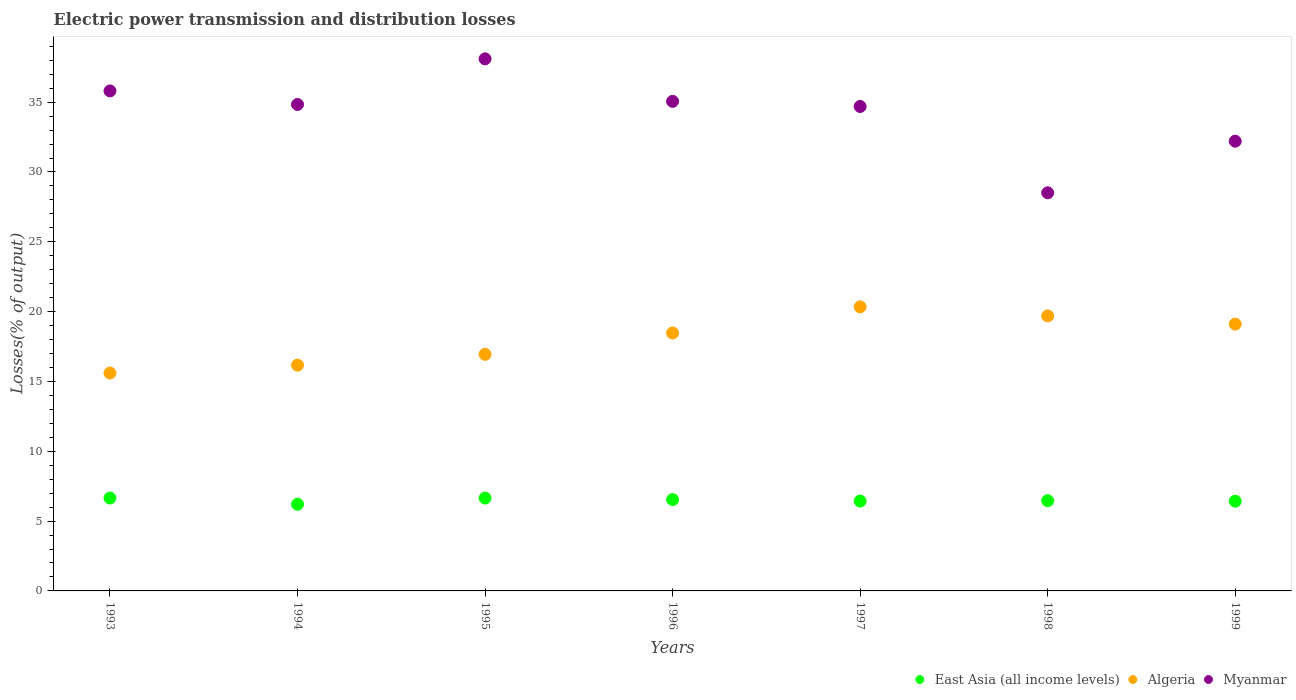Is the number of dotlines equal to the number of legend labels?
Your answer should be compact. Yes. What is the electric power transmission and distribution losses in Algeria in 1999?
Provide a short and direct response. 19.11. Across all years, what is the maximum electric power transmission and distribution losses in Myanmar?
Provide a succinct answer. 38.1. Across all years, what is the minimum electric power transmission and distribution losses in East Asia (all income levels)?
Your response must be concise. 6.21. In which year was the electric power transmission and distribution losses in Myanmar minimum?
Make the answer very short. 1998. What is the total electric power transmission and distribution losses in Algeria in the graph?
Your answer should be compact. 126.32. What is the difference between the electric power transmission and distribution losses in Algeria in 1995 and that in 1998?
Provide a succinct answer. -2.75. What is the difference between the electric power transmission and distribution losses in East Asia (all income levels) in 1993 and the electric power transmission and distribution losses in Algeria in 1994?
Your answer should be very brief. -9.51. What is the average electric power transmission and distribution losses in East Asia (all income levels) per year?
Give a very brief answer. 6.48. In the year 1994, what is the difference between the electric power transmission and distribution losses in East Asia (all income levels) and electric power transmission and distribution losses in Algeria?
Provide a short and direct response. -9.96. What is the ratio of the electric power transmission and distribution losses in Myanmar in 1997 to that in 1999?
Your answer should be very brief. 1.08. Is the difference between the electric power transmission and distribution losses in East Asia (all income levels) in 1993 and 1995 greater than the difference between the electric power transmission and distribution losses in Algeria in 1993 and 1995?
Your answer should be compact. Yes. What is the difference between the highest and the second highest electric power transmission and distribution losses in Myanmar?
Ensure brevity in your answer.  2.3. What is the difference between the highest and the lowest electric power transmission and distribution losses in Myanmar?
Provide a succinct answer. 9.59. In how many years, is the electric power transmission and distribution losses in Myanmar greater than the average electric power transmission and distribution losses in Myanmar taken over all years?
Offer a very short reply. 5. Is the sum of the electric power transmission and distribution losses in Algeria in 1995 and 1999 greater than the maximum electric power transmission and distribution losses in Myanmar across all years?
Ensure brevity in your answer.  No. Does the electric power transmission and distribution losses in East Asia (all income levels) monotonically increase over the years?
Provide a short and direct response. No. Is the electric power transmission and distribution losses in Algeria strictly less than the electric power transmission and distribution losses in East Asia (all income levels) over the years?
Your answer should be very brief. No. How many years are there in the graph?
Provide a short and direct response. 7. What is the difference between two consecutive major ticks on the Y-axis?
Make the answer very short. 5. Are the values on the major ticks of Y-axis written in scientific E-notation?
Offer a terse response. No. Does the graph contain grids?
Offer a terse response. No. Where does the legend appear in the graph?
Provide a succinct answer. Bottom right. How many legend labels are there?
Ensure brevity in your answer.  3. How are the legend labels stacked?
Keep it short and to the point. Horizontal. What is the title of the graph?
Give a very brief answer. Electric power transmission and distribution losses. What is the label or title of the Y-axis?
Provide a short and direct response. Losses(% of output). What is the Losses(% of output) of East Asia (all income levels) in 1993?
Provide a short and direct response. 6.65. What is the Losses(% of output) in Algeria in 1993?
Provide a short and direct response. 15.6. What is the Losses(% of output) of Myanmar in 1993?
Make the answer very short. 35.81. What is the Losses(% of output) in East Asia (all income levels) in 1994?
Your response must be concise. 6.21. What is the Losses(% of output) of Algeria in 1994?
Your response must be concise. 16.16. What is the Losses(% of output) in Myanmar in 1994?
Give a very brief answer. 34.84. What is the Losses(% of output) of East Asia (all income levels) in 1995?
Your answer should be compact. 6.65. What is the Losses(% of output) in Algeria in 1995?
Offer a terse response. 16.94. What is the Losses(% of output) in Myanmar in 1995?
Provide a short and direct response. 38.1. What is the Losses(% of output) of East Asia (all income levels) in 1996?
Ensure brevity in your answer.  6.54. What is the Losses(% of output) in Algeria in 1996?
Provide a succinct answer. 18.47. What is the Losses(% of output) in Myanmar in 1996?
Your response must be concise. 35.06. What is the Losses(% of output) in East Asia (all income levels) in 1997?
Keep it short and to the point. 6.43. What is the Losses(% of output) in Algeria in 1997?
Ensure brevity in your answer.  20.34. What is the Losses(% of output) in Myanmar in 1997?
Your answer should be compact. 34.69. What is the Losses(% of output) in East Asia (all income levels) in 1998?
Offer a very short reply. 6.46. What is the Losses(% of output) of Algeria in 1998?
Provide a succinct answer. 19.69. What is the Losses(% of output) of Myanmar in 1998?
Provide a succinct answer. 28.51. What is the Losses(% of output) in East Asia (all income levels) in 1999?
Give a very brief answer. 6.42. What is the Losses(% of output) in Algeria in 1999?
Ensure brevity in your answer.  19.11. What is the Losses(% of output) of Myanmar in 1999?
Offer a very short reply. 32.21. Across all years, what is the maximum Losses(% of output) in East Asia (all income levels)?
Your answer should be very brief. 6.65. Across all years, what is the maximum Losses(% of output) of Algeria?
Your answer should be very brief. 20.34. Across all years, what is the maximum Losses(% of output) in Myanmar?
Your answer should be very brief. 38.1. Across all years, what is the minimum Losses(% of output) of East Asia (all income levels)?
Keep it short and to the point. 6.21. Across all years, what is the minimum Losses(% of output) in Algeria?
Offer a terse response. 15.6. Across all years, what is the minimum Losses(% of output) in Myanmar?
Your answer should be very brief. 28.51. What is the total Losses(% of output) in East Asia (all income levels) in the graph?
Offer a very short reply. 45.37. What is the total Losses(% of output) in Algeria in the graph?
Offer a terse response. 126.32. What is the total Losses(% of output) of Myanmar in the graph?
Make the answer very short. 239.2. What is the difference between the Losses(% of output) in East Asia (all income levels) in 1993 and that in 1994?
Your answer should be very brief. 0.45. What is the difference between the Losses(% of output) in Algeria in 1993 and that in 1994?
Offer a terse response. -0.56. What is the difference between the Losses(% of output) of Myanmar in 1993 and that in 1994?
Provide a succinct answer. 0.97. What is the difference between the Losses(% of output) of East Asia (all income levels) in 1993 and that in 1995?
Your response must be concise. 0. What is the difference between the Losses(% of output) in Algeria in 1993 and that in 1995?
Make the answer very short. -1.34. What is the difference between the Losses(% of output) of Myanmar in 1993 and that in 1995?
Keep it short and to the point. -2.3. What is the difference between the Losses(% of output) in East Asia (all income levels) in 1993 and that in 1996?
Offer a very short reply. 0.11. What is the difference between the Losses(% of output) in Algeria in 1993 and that in 1996?
Ensure brevity in your answer.  -2.87. What is the difference between the Losses(% of output) of Myanmar in 1993 and that in 1996?
Make the answer very short. 0.75. What is the difference between the Losses(% of output) of East Asia (all income levels) in 1993 and that in 1997?
Your response must be concise. 0.22. What is the difference between the Losses(% of output) of Algeria in 1993 and that in 1997?
Your answer should be very brief. -4.74. What is the difference between the Losses(% of output) of Myanmar in 1993 and that in 1997?
Your answer should be compact. 1.11. What is the difference between the Losses(% of output) in East Asia (all income levels) in 1993 and that in 1998?
Keep it short and to the point. 0.19. What is the difference between the Losses(% of output) of Algeria in 1993 and that in 1998?
Offer a terse response. -4.09. What is the difference between the Losses(% of output) in Myanmar in 1993 and that in 1998?
Offer a terse response. 7.3. What is the difference between the Losses(% of output) of East Asia (all income levels) in 1993 and that in 1999?
Provide a succinct answer. 0.23. What is the difference between the Losses(% of output) in Algeria in 1993 and that in 1999?
Offer a very short reply. -3.5. What is the difference between the Losses(% of output) in Myanmar in 1993 and that in 1999?
Your answer should be compact. 3.6. What is the difference between the Losses(% of output) of East Asia (all income levels) in 1994 and that in 1995?
Provide a succinct answer. -0.44. What is the difference between the Losses(% of output) in Algeria in 1994 and that in 1995?
Ensure brevity in your answer.  -0.78. What is the difference between the Losses(% of output) of Myanmar in 1994 and that in 1995?
Your answer should be compact. -3.27. What is the difference between the Losses(% of output) of East Asia (all income levels) in 1994 and that in 1996?
Your response must be concise. -0.34. What is the difference between the Losses(% of output) of Algeria in 1994 and that in 1996?
Offer a very short reply. -2.31. What is the difference between the Losses(% of output) of Myanmar in 1994 and that in 1996?
Provide a short and direct response. -0.22. What is the difference between the Losses(% of output) in East Asia (all income levels) in 1994 and that in 1997?
Provide a short and direct response. -0.23. What is the difference between the Losses(% of output) in Algeria in 1994 and that in 1997?
Give a very brief answer. -4.18. What is the difference between the Losses(% of output) of Myanmar in 1994 and that in 1997?
Offer a terse response. 0.15. What is the difference between the Losses(% of output) of East Asia (all income levels) in 1994 and that in 1998?
Offer a terse response. -0.26. What is the difference between the Losses(% of output) in Algeria in 1994 and that in 1998?
Your answer should be very brief. -3.53. What is the difference between the Losses(% of output) of Myanmar in 1994 and that in 1998?
Your response must be concise. 6.33. What is the difference between the Losses(% of output) in East Asia (all income levels) in 1994 and that in 1999?
Provide a succinct answer. -0.22. What is the difference between the Losses(% of output) of Algeria in 1994 and that in 1999?
Your response must be concise. -2.94. What is the difference between the Losses(% of output) in Myanmar in 1994 and that in 1999?
Provide a short and direct response. 2.63. What is the difference between the Losses(% of output) of East Asia (all income levels) in 1995 and that in 1996?
Ensure brevity in your answer.  0.11. What is the difference between the Losses(% of output) of Algeria in 1995 and that in 1996?
Keep it short and to the point. -1.53. What is the difference between the Losses(% of output) in Myanmar in 1995 and that in 1996?
Ensure brevity in your answer.  3.04. What is the difference between the Losses(% of output) in East Asia (all income levels) in 1995 and that in 1997?
Ensure brevity in your answer.  0.22. What is the difference between the Losses(% of output) of Algeria in 1995 and that in 1997?
Offer a very short reply. -3.4. What is the difference between the Losses(% of output) of Myanmar in 1995 and that in 1997?
Your answer should be very brief. 3.41. What is the difference between the Losses(% of output) in East Asia (all income levels) in 1995 and that in 1998?
Offer a terse response. 0.19. What is the difference between the Losses(% of output) of Algeria in 1995 and that in 1998?
Your response must be concise. -2.75. What is the difference between the Losses(% of output) in Myanmar in 1995 and that in 1998?
Ensure brevity in your answer.  9.59. What is the difference between the Losses(% of output) in East Asia (all income levels) in 1995 and that in 1999?
Your answer should be very brief. 0.22. What is the difference between the Losses(% of output) of Algeria in 1995 and that in 1999?
Provide a short and direct response. -2.16. What is the difference between the Losses(% of output) in Myanmar in 1995 and that in 1999?
Give a very brief answer. 5.9. What is the difference between the Losses(% of output) of East Asia (all income levels) in 1996 and that in 1997?
Provide a short and direct response. 0.11. What is the difference between the Losses(% of output) of Algeria in 1996 and that in 1997?
Give a very brief answer. -1.87. What is the difference between the Losses(% of output) of Myanmar in 1996 and that in 1997?
Offer a very short reply. 0.37. What is the difference between the Losses(% of output) in East Asia (all income levels) in 1996 and that in 1998?
Your answer should be very brief. 0.08. What is the difference between the Losses(% of output) of Algeria in 1996 and that in 1998?
Your answer should be very brief. -1.22. What is the difference between the Losses(% of output) of Myanmar in 1996 and that in 1998?
Your answer should be compact. 6.55. What is the difference between the Losses(% of output) of East Asia (all income levels) in 1996 and that in 1999?
Offer a terse response. 0.12. What is the difference between the Losses(% of output) of Algeria in 1996 and that in 1999?
Keep it short and to the point. -0.63. What is the difference between the Losses(% of output) in Myanmar in 1996 and that in 1999?
Give a very brief answer. 2.85. What is the difference between the Losses(% of output) in East Asia (all income levels) in 1997 and that in 1998?
Your answer should be very brief. -0.03. What is the difference between the Losses(% of output) of Algeria in 1997 and that in 1998?
Give a very brief answer. 0.65. What is the difference between the Losses(% of output) in Myanmar in 1997 and that in 1998?
Your answer should be compact. 6.18. What is the difference between the Losses(% of output) in East Asia (all income levels) in 1997 and that in 1999?
Give a very brief answer. 0.01. What is the difference between the Losses(% of output) in Algeria in 1997 and that in 1999?
Offer a terse response. 1.24. What is the difference between the Losses(% of output) of Myanmar in 1997 and that in 1999?
Your answer should be compact. 2.49. What is the difference between the Losses(% of output) of East Asia (all income levels) in 1998 and that in 1999?
Provide a succinct answer. 0.04. What is the difference between the Losses(% of output) in Algeria in 1998 and that in 1999?
Provide a succinct answer. 0.59. What is the difference between the Losses(% of output) of Myanmar in 1998 and that in 1999?
Make the answer very short. -3.7. What is the difference between the Losses(% of output) in East Asia (all income levels) in 1993 and the Losses(% of output) in Algeria in 1994?
Give a very brief answer. -9.51. What is the difference between the Losses(% of output) in East Asia (all income levels) in 1993 and the Losses(% of output) in Myanmar in 1994?
Make the answer very short. -28.18. What is the difference between the Losses(% of output) of Algeria in 1993 and the Losses(% of output) of Myanmar in 1994?
Provide a short and direct response. -19.23. What is the difference between the Losses(% of output) of East Asia (all income levels) in 1993 and the Losses(% of output) of Algeria in 1995?
Keep it short and to the point. -10.29. What is the difference between the Losses(% of output) of East Asia (all income levels) in 1993 and the Losses(% of output) of Myanmar in 1995?
Ensure brevity in your answer.  -31.45. What is the difference between the Losses(% of output) in Algeria in 1993 and the Losses(% of output) in Myanmar in 1995?
Your answer should be compact. -22.5. What is the difference between the Losses(% of output) in East Asia (all income levels) in 1993 and the Losses(% of output) in Algeria in 1996?
Provide a short and direct response. -11.82. What is the difference between the Losses(% of output) in East Asia (all income levels) in 1993 and the Losses(% of output) in Myanmar in 1996?
Provide a short and direct response. -28.41. What is the difference between the Losses(% of output) of Algeria in 1993 and the Losses(% of output) of Myanmar in 1996?
Offer a very short reply. -19.45. What is the difference between the Losses(% of output) in East Asia (all income levels) in 1993 and the Losses(% of output) in Algeria in 1997?
Provide a short and direct response. -13.69. What is the difference between the Losses(% of output) in East Asia (all income levels) in 1993 and the Losses(% of output) in Myanmar in 1997?
Give a very brief answer. -28.04. What is the difference between the Losses(% of output) in Algeria in 1993 and the Losses(% of output) in Myanmar in 1997?
Your answer should be compact. -19.09. What is the difference between the Losses(% of output) of East Asia (all income levels) in 1993 and the Losses(% of output) of Algeria in 1998?
Your response must be concise. -13.04. What is the difference between the Losses(% of output) of East Asia (all income levels) in 1993 and the Losses(% of output) of Myanmar in 1998?
Offer a very short reply. -21.86. What is the difference between the Losses(% of output) in Algeria in 1993 and the Losses(% of output) in Myanmar in 1998?
Your response must be concise. -12.91. What is the difference between the Losses(% of output) of East Asia (all income levels) in 1993 and the Losses(% of output) of Algeria in 1999?
Provide a succinct answer. -12.45. What is the difference between the Losses(% of output) of East Asia (all income levels) in 1993 and the Losses(% of output) of Myanmar in 1999?
Offer a terse response. -25.55. What is the difference between the Losses(% of output) in Algeria in 1993 and the Losses(% of output) in Myanmar in 1999?
Give a very brief answer. -16.6. What is the difference between the Losses(% of output) of East Asia (all income levels) in 1994 and the Losses(% of output) of Algeria in 1995?
Ensure brevity in your answer.  -10.74. What is the difference between the Losses(% of output) of East Asia (all income levels) in 1994 and the Losses(% of output) of Myanmar in 1995?
Offer a terse response. -31.9. What is the difference between the Losses(% of output) of Algeria in 1994 and the Losses(% of output) of Myanmar in 1995?
Provide a succinct answer. -21.94. What is the difference between the Losses(% of output) of East Asia (all income levels) in 1994 and the Losses(% of output) of Algeria in 1996?
Offer a terse response. -12.27. What is the difference between the Losses(% of output) of East Asia (all income levels) in 1994 and the Losses(% of output) of Myanmar in 1996?
Your response must be concise. -28.85. What is the difference between the Losses(% of output) of Algeria in 1994 and the Losses(% of output) of Myanmar in 1996?
Provide a short and direct response. -18.89. What is the difference between the Losses(% of output) of East Asia (all income levels) in 1994 and the Losses(% of output) of Algeria in 1997?
Give a very brief answer. -14.14. What is the difference between the Losses(% of output) in East Asia (all income levels) in 1994 and the Losses(% of output) in Myanmar in 1997?
Make the answer very short. -28.48. What is the difference between the Losses(% of output) of Algeria in 1994 and the Losses(% of output) of Myanmar in 1997?
Your answer should be compact. -18.53. What is the difference between the Losses(% of output) of East Asia (all income levels) in 1994 and the Losses(% of output) of Algeria in 1998?
Your answer should be compact. -13.49. What is the difference between the Losses(% of output) in East Asia (all income levels) in 1994 and the Losses(% of output) in Myanmar in 1998?
Make the answer very short. -22.3. What is the difference between the Losses(% of output) of Algeria in 1994 and the Losses(% of output) of Myanmar in 1998?
Your answer should be very brief. -12.34. What is the difference between the Losses(% of output) in East Asia (all income levels) in 1994 and the Losses(% of output) in Algeria in 1999?
Provide a short and direct response. -12.9. What is the difference between the Losses(% of output) in East Asia (all income levels) in 1994 and the Losses(% of output) in Myanmar in 1999?
Provide a succinct answer. -26. What is the difference between the Losses(% of output) in Algeria in 1994 and the Losses(% of output) in Myanmar in 1999?
Your response must be concise. -16.04. What is the difference between the Losses(% of output) of East Asia (all income levels) in 1995 and the Losses(% of output) of Algeria in 1996?
Ensure brevity in your answer.  -11.82. What is the difference between the Losses(% of output) of East Asia (all income levels) in 1995 and the Losses(% of output) of Myanmar in 1996?
Provide a succinct answer. -28.41. What is the difference between the Losses(% of output) of Algeria in 1995 and the Losses(% of output) of Myanmar in 1996?
Offer a terse response. -18.12. What is the difference between the Losses(% of output) in East Asia (all income levels) in 1995 and the Losses(% of output) in Algeria in 1997?
Your answer should be compact. -13.69. What is the difference between the Losses(% of output) of East Asia (all income levels) in 1995 and the Losses(% of output) of Myanmar in 1997?
Your answer should be very brief. -28.04. What is the difference between the Losses(% of output) in Algeria in 1995 and the Losses(% of output) in Myanmar in 1997?
Give a very brief answer. -17.75. What is the difference between the Losses(% of output) in East Asia (all income levels) in 1995 and the Losses(% of output) in Algeria in 1998?
Offer a very short reply. -13.04. What is the difference between the Losses(% of output) in East Asia (all income levels) in 1995 and the Losses(% of output) in Myanmar in 1998?
Keep it short and to the point. -21.86. What is the difference between the Losses(% of output) in Algeria in 1995 and the Losses(% of output) in Myanmar in 1998?
Make the answer very short. -11.57. What is the difference between the Losses(% of output) in East Asia (all income levels) in 1995 and the Losses(% of output) in Algeria in 1999?
Provide a succinct answer. -12.46. What is the difference between the Losses(% of output) of East Asia (all income levels) in 1995 and the Losses(% of output) of Myanmar in 1999?
Provide a succinct answer. -25.56. What is the difference between the Losses(% of output) of Algeria in 1995 and the Losses(% of output) of Myanmar in 1999?
Give a very brief answer. -15.26. What is the difference between the Losses(% of output) of East Asia (all income levels) in 1996 and the Losses(% of output) of Algeria in 1997?
Ensure brevity in your answer.  -13.8. What is the difference between the Losses(% of output) of East Asia (all income levels) in 1996 and the Losses(% of output) of Myanmar in 1997?
Offer a very short reply. -28.15. What is the difference between the Losses(% of output) of Algeria in 1996 and the Losses(% of output) of Myanmar in 1997?
Your answer should be very brief. -16.22. What is the difference between the Losses(% of output) in East Asia (all income levels) in 1996 and the Losses(% of output) in Algeria in 1998?
Offer a terse response. -13.15. What is the difference between the Losses(% of output) in East Asia (all income levels) in 1996 and the Losses(% of output) in Myanmar in 1998?
Keep it short and to the point. -21.97. What is the difference between the Losses(% of output) of Algeria in 1996 and the Losses(% of output) of Myanmar in 1998?
Offer a very short reply. -10.04. What is the difference between the Losses(% of output) of East Asia (all income levels) in 1996 and the Losses(% of output) of Algeria in 1999?
Make the answer very short. -12.56. What is the difference between the Losses(% of output) in East Asia (all income levels) in 1996 and the Losses(% of output) in Myanmar in 1999?
Provide a short and direct response. -25.66. What is the difference between the Losses(% of output) of Algeria in 1996 and the Losses(% of output) of Myanmar in 1999?
Your answer should be compact. -13.73. What is the difference between the Losses(% of output) in East Asia (all income levels) in 1997 and the Losses(% of output) in Algeria in 1998?
Provide a succinct answer. -13.26. What is the difference between the Losses(% of output) in East Asia (all income levels) in 1997 and the Losses(% of output) in Myanmar in 1998?
Give a very brief answer. -22.08. What is the difference between the Losses(% of output) in Algeria in 1997 and the Losses(% of output) in Myanmar in 1998?
Make the answer very short. -8.17. What is the difference between the Losses(% of output) in East Asia (all income levels) in 1997 and the Losses(% of output) in Algeria in 1999?
Your answer should be very brief. -12.67. What is the difference between the Losses(% of output) of East Asia (all income levels) in 1997 and the Losses(% of output) of Myanmar in 1999?
Offer a terse response. -25.77. What is the difference between the Losses(% of output) in Algeria in 1997 and the Losses(% of output) in Myanmar in 1999?
Ensure brevity in your answer.  -11.86. What is the difference between the Losses(% of output) in East Asia (all income levels) in 1998 and the Losses(% of output) in Algeria in 1999?
Offer a very short reply. -12.64. What is the difference between the Losses(% of output) in East Asia (all income levels) in 1998 and the Losses(% of output) in Myanmar in 1999?
Keep it short and to the point. -25.74. What is the difference between the Losses(% of output) of Algeria in 1998 and the Losses(% of output) of Myanmar in 1999?
Your response must be concise. -12.51. What is the average Losses(% of output) of East Asia (all income levels) per year?
Provide a short and direct response. 6.48. What is the average Losses(% of output) in Algeria per year?
Give a very brief answer. 18.05. What is the average Losses(% of output) of Myanmar per year?
Offer a very short reply. 34.17. In the year 1993, what is the difference between the Losses(% of output) of East Asia (all income levels) and Losses(% of output) of Algeria?
Your answer should be very brief. -8.95. In the year 1993, what is the difference between the Losses(% of output) in East Asia (all income levels) and Losses(% of output) in Myanmar?
Provide a short and direct response. -29.15. In the year 1993, what is the difference between the Losses(% of output) in Algeria and Losses(% of output) in Myanmar?
Provide a succinct answer. -20.2. In the year 1994, what is the difference between the Losses(% of output) of East Asia (all income levels) and Losses(% of output) of Algeria?
Keep it short and to the point. -9.96. In the year 1994, what is the difference between the Losses(% of output) of East Asia (all income levels) and Losses(% of output) of Myanmar?
Give a very brief answer. -28.63. In the year 1994, what is the difference between the Losses(% of output) in Algeria and Losses(% of output) in Myanmar?
Keep it short and to the point. -18.67. In the year 1995, what is the difference between the Losses(% of output) in East Asia (all income levels) and Losses(% of output) in Algeria?
Keep it short and to the point. -10.29. In the year 1995, what is the difference between the Losses(% of output) in East Asia (all income levels) and Losses(% of output) in Myanmar?
Provide a short and direct response. -31.45. In the year 1995, what is the difference between the Losses(% of output) of Algeria and Losses(% of output) of Myanmar?
Offer a terse response. -21.16. In the year 1996, what is the difference between the Losses(% of output) in East Asia (all income levels) and Losses(% of output) in Algeria?
Keep it short and to the point. -11.93. In the year 1996, what is the difference between the Losses(% of output) in East Asia (all income levels) and Losses(% of output) in Myanmar?
Offer a very short reply. -28.51. In the year 1996, what is the difference between the Losses(% of output) in Algeria and Losses(% of output) in Myanmar?
Offer a very short reply. -16.59. In the year 1997, what is the difference between the Losses(% of output) of East Asia (all income levels) and Losses(% of output) of Algeria?
Offer a very short reply. -13.91. In the year 1997, what is the difference between the Losses(% of output) of East Asia (all income levels) and Losses(% of output) of Myanmar?
Make the answer very short. -28.26. In the year 1997, what is the difference between the Losses(% of output) in Algeria and Losses(% of output) in Myanmar?
Keep it short and to the point. -14.35. In the year 1998, what is the difference between the Losses(% of output) in East Asia (all income levels) and Losses(% of output) in Algeria?
Give a very brief answer. -13.23. In the year 1998, what is the difference between the Losses(% of output) in East Asia (all income levels) and Losses(% of output) in Myanmar?
Your response must be concise. -22.05. In the year 1998, what is the difference between the Losses(% of output) of Algeria and Losses(% of output) of Myanmar?
Your answer should be compact. -8.82. In the year 1999, what is the difference between the Losses(% of output) in East Asia (all income levels) and Losses(% of output) in Algeria?
Your response must be concise. -12.68. In the year 1999, what is the difference between the Losses(% of output) of East Asia (all income levels) and Losses(% of output) of Myanmar?
Ensure brevity in your answer.  -25.78. In the year 1999, what is the difference between the Losses(% of output) in Algeria and Losses(% of output) in Myanmar?
Give a very brief answer. -13.1. What is the ratio of the Losses(% of output) of East Asia (all income levels) in 1993 to that in 1994?
Make the answer very short. 1.07. What is the ratio of the Losses(% of output) of Algeria in 1993 to that in 1994?
Provide a short and direct response. 0.97. What is the ratio of the Losses(% of output) of Myanmar in 1993 to that in 1994?
Offer a very short reply. 1.03. What is the ratio of the Losses(% of output) in East Asia (all income levels) in 1993 to that in 1995?
Ensure brevity in your answer.  1. What is the ratio of the Losses(% of output) in Algeria in 1993 to that in 1995?
Provide a short and direct response. 0.92. What is the ratio of the Losses(% of output) in Myanmar in 1993 to that in 1995?
Make the answer very short. 0.94. What is the ratio of the Losses(% of output) of East Asia (all income levels) in 1993 to that in 1996?
Provide a short and direct response. 1.02. What is the ratio of the Losses(% of output) of Algeria in 1993 to that in 1996?
Provide a succinct answer. 0.84. What is the ratio of the Losses(% of output) of Myanmar in 1993 to that in 1996?
Keep it short and to the point. 1.02. What is the ratio of the Losses(% of output) of East Asia (all income levels) in 1993 to that in 1997?
Give a very brief answer. 1.03. What is the ratio of the Losses(% of output) of Algeria in 1993 to that in 1997?
Your answer should be compact. 0.77. What is the ratio of the Losses(% of output) in Myanmar in 1993 to that in 1997?
Keep it short and to the point. 1.03. What is the ratio of the Losses(% of output) in East Asia (all income levels) in 1993 to that in 1998?
Your response must be concise. 1.03. What is the ratio of the Losses(% of output) in Algeria in 1993 to that in 1998?
Offer a very short reply. 0.79. What is the ratio of the Losses(% of output) in Myanmar in 1993 to that in 1998?
Ensure brevity in your answer.  1.26. What is the ratio of the Losses(% of output) of East Asia (all income levels) in 1993 to that in 1999?
Keep it short and to the point. 1.04. What is the ratio of the Losses(% of output) of Algeria in 1993 to that in 1999?
Offer a very short reply. 0.82. What is the ratio of the Losses(% of output) of Myanmar in 1993 to that in 1999?
Your answer should be compact. 1.11. What is the ratio of the Losses(% of output) in East Asia (all income levels) in 1994 to that in 1995?
Your answer should be compact. 0.93. What is the ratio of the Losses(% of output) in Algeria in 1994 to that in 1995?
Provide a succinct answer. 0.95. What is the ratio of the Losses(% of output) of Myanmar in 1994 to that in 1995?
Your answer should be very brief. 0.91. What is the ratio of the Losses(% of output) in East Asia (all income levels) in 1994 to that in 1996?
Provide a succinct answer. 0.95. What is the ratio of the Losses(% of output) in Algeria in 1994 to that in 1996?
Offer a terse response. 0.88. What is the ratio of the Losses(% of output) in East Asia (all income levels) in 1994 to that in 1997?
Keep it short and to the point. 0.96. What is the ratio of the Losses(% of output) in Algeria in 1994 to that in 1997?
Provide a succinct answer. 0.79. What is the ratio of the Losses(% of output) in Myanmar in 1994 to that in 1997?
Your answer should be very brief. 1. What is the ratio of the Losses(% of output) of East Asia (all income levels) in 1994 to that in 1998?
Provide a succinct answer. 0.96. What is the ratio of the Losses(% of output) of Algeria in 1994 to that in 1998?
Provide a succinct answer. 0.82. What is the ratio of the Losses(% of output) in Myanmar in 1994 to that in 1998?
Your answer should be very brief. 1.22. What is the ratio of the Losses(% of output) in East Asia (all income levels) in 1994 to that in 1999?
Keep it short and to the point. 0.97. What is the ratio of the Losses(% of output) in Algeria in 1994 to that in 1999?
Give a very brief answer. 0.85. What is the ratio of the Losses(% of output) in Myanmar in 1994 to that in 1999?
Give a very brief answer. 1.08. What is the ratio of the Losses(% of output) of East Asia (all income levels) in 1995 to that in 1996?
Your answer should be compact. 1.02. What is the ratio of the Losses(% of output) in Algeria in 1995 to that in 1996?
Make the answer very short. 0.92. What is the ratio of the Losses(% of output) in Myanmar in 1995 to that in 1996?
Keep it short and to the point. 1.09. What is the ratio of the Losses(% of output) in East Asia (all income levels) in 1995 to that in 1997?
Your answer should be compact. 1.03. What is the ratio of the Losses(% of output) in Algeria in 1995 to that in 1997?
Give a very brief answer. 0.83. What is the ratio of the Losses(% of output) in Myanmar in 1995 to that in 1997?
Give a very brief answer. 1.1. What is the ratio of the Losses(% of output) of East Asia (all income levels) in 1995 to that in 1998?
Offer a very short reply. 1.03. What is the ratio of the Losses(% of output) of Algeria in 1995 to that in 1998?
Offer a very short reply. 0.86. What is the ratio of the Losses(% of output) in Myanmar in 1995 to that in 1998?
Provide a succinct answer. 1.34. What is the ratio of the Losses(% of output) in East Asia (all income levels) in 1995 to that in 1999?
Give a very brief answer. 1.03. What is the ratio of the Losses(% of output) of Algeria in 1995 to that in 1999?
Your answer should be compact. 0.89. What is the ratio of the Losses(% of output) of Myanmar in 1995 to that in 1999?
Your answer should be compact. 1.18. What is the ratio of the Losses(% of output) in Algeria in 1996 to that in 1997?
Your answer should be very brief. 0.91. What is the ratio of the Losses(% of output) in Myanmar in 1996 to that in 1997?
Offer a very short reply. 1.01. What is the ratio of the Losses(% of output) of East Asia (all income levels) in 1996 to that in 1998?
Your answer should be very brief. 1.01. What is the ratio of the Losses(% of output) of Algeria in 1996 to that in 1998?
Your response must be concise. 0.94. What is the ratio of the Losses(% of output) in Myanmar in 1996 to that in 1998?
Give a very brief answer. 1.23. What is the ratio of the Losses(% of output) in East Asia (all income levels) in 1996 to that in 1999?
Give a very brief answer. 1.02. What is the ratio of the Losses(% of output) of Algeria in 1996 to that in 1999?
Provide a short and direct response. 0.97. What is the ratio of the Losses(% of output) of Myanmar in 1996 to that in 1999?
Keep it short and to the point. 1.09. What is the ratio of the Losses(% of output) of Algeria in 1997 to that in 1998?
Give a very brief answer. 1.03. What is the ratio of the Losses(% of output) in Myanmar in 1997 to that in 1998?
Make the answer very short. 1.22. What is the ratio of the Losses(% of output) of East Asia (all income levels) in 1997 to that in 1999?
Provide a short and direct response. 1. What is the ratio of the Losses(% of output) in Algeria in 1997 to that in 1999?
Your answer should be compact. 1.06. What is the ratio of the Losses(% of output) of Myanmar in 1997 to that in 1999?
Keep it short and to the point. 1.08. What is the ratio of the Losses(% of output) in Algeria in 1998 to that in 1999?
Give a very brief answer. 1.03. What is the ratio of the Losses(% of output) in Myanmar in 1998 to that in 1999?
Make the answer very short. 0.89. What is the difference between the highest and the second highest Losses(% of output) in East Asia (all income levels)?
Provide a short and direct response. 0. What is the difference between the highest and the second highest Losses(% of output) of Algeria?
Provide a short and direct response. 0.65. What is the difference between the highest and the second highest Losses(% of output) in Myanmar?
Keep it short and to the point. 2.3. What is the difference between the highest and the lowest Losses(% of output) of East Asia (all income levels)?
Keep it short and to the point. 0.45. What is the difference between the highest and the lowest Losses(% of output) of Algeria?
Your answer should be very brief. 4.74. What is the difference between the highest and the lowest Losses(% of output) in Myanmar?
Your answer should be very brief. 9.59. 